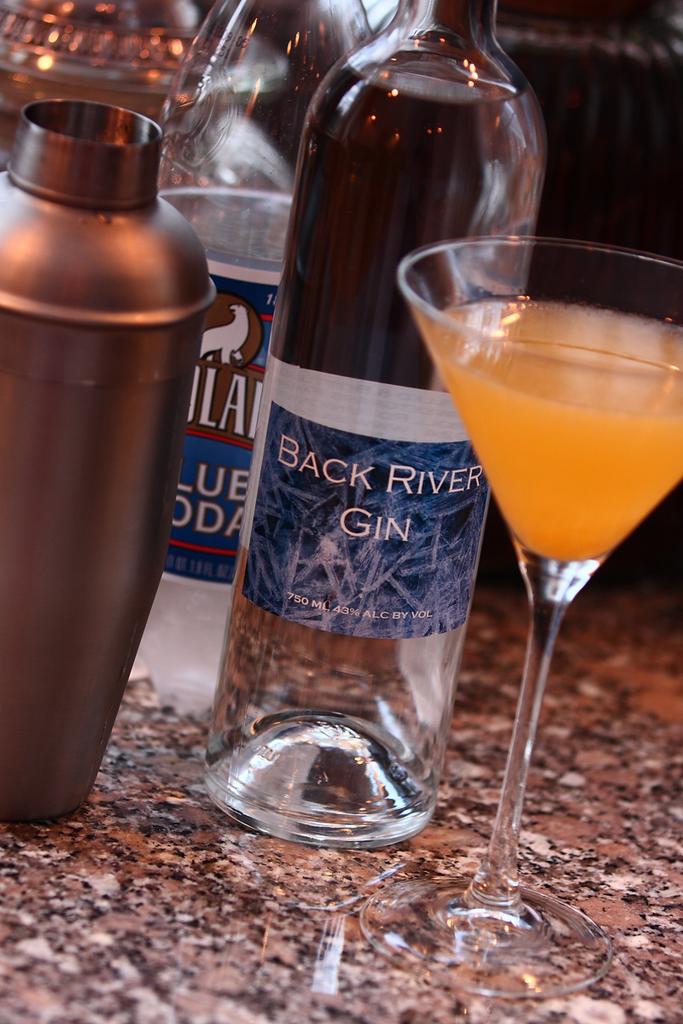What kind of drink is in the near clear bottle?
Offer a terse response. Gin. What volume of back river gin does the bottle on the right hold?
Offer a very short reply. 750 ml. 